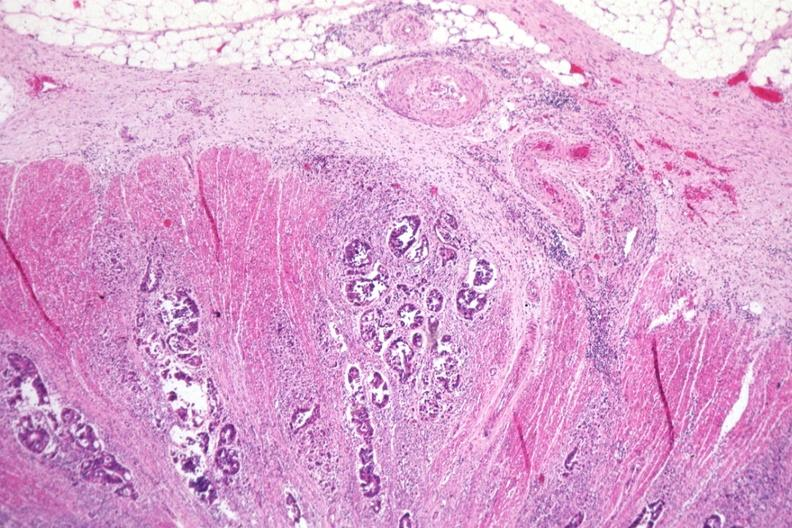s edema present?
Answer the question using a single word or phrase. No 